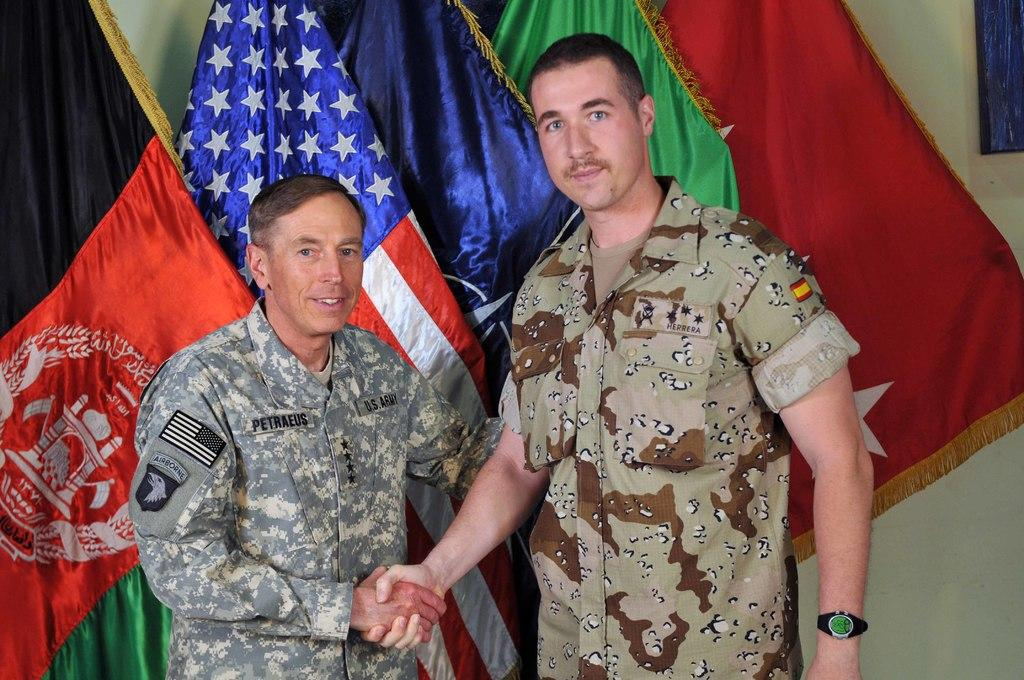<image>
Relay a brief, clear account of the picture shown. Soldier Herrera is standing to the right in the picture. 